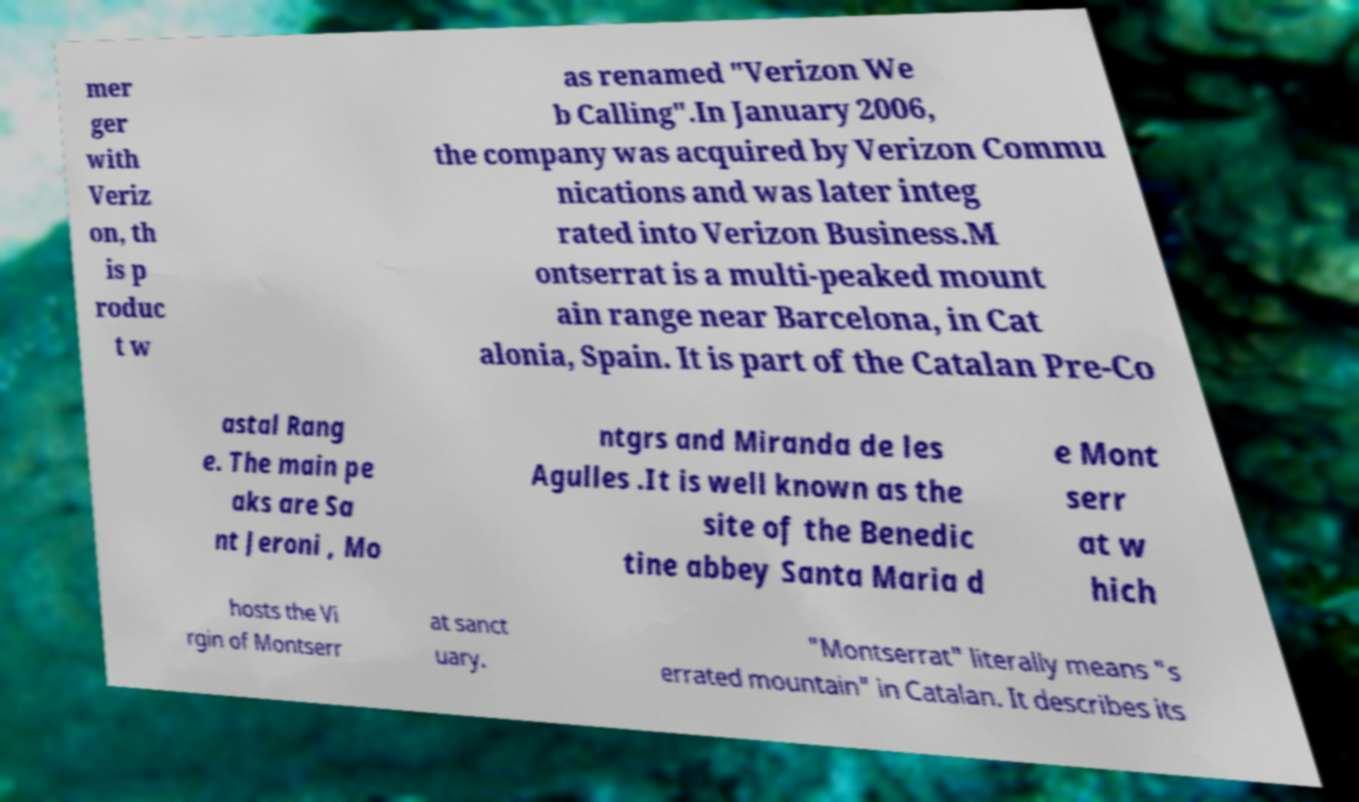Please read and relay the text visible in this image. What does it say? mer ger with Veriz on, th is p roduc t w as renamed "Verizon We b Calling".In January 2006, the company was acquired by Verizon Commu nications and was later integ rated into Verizon Business.M ontserrat is a multi-peaked mount ain range near Barcelona, in Cat alonia, Spain. It is part of the Catalan Pre-Co astal Rang e. The main pe aks are Sa nt Jeroni , Mo ntgrs and Miranda de les Agulles .It is well known as the site of the Benedic tine abbey Santa Maria d e Mont serr at w hich hosts the Vi rgin of Montserr at sanct uary. "Montserrat" literally means "s errated mountain" in Catalan. It describes its 